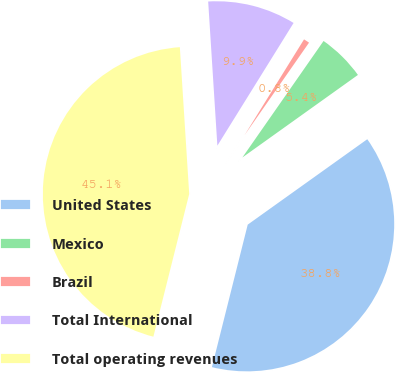Convert chart to OTSL. <chart><loc_0><loc_0><loc_500><loc_500><pie_chart><fcel>United States<fcel>Mexico<fcel>Brazil<fcel>Total International<fcel>Total operating revenues<nl><fcel>38.79%<fcel>5.44%<fcel>0.84%<fcel>9.86%<fcel>45.07%<nl></chart> 